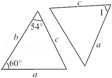Enumerate the features presented in the diagram. The diagram displays two triangles labeled as ABC and DEF. In triangle ABC, angles at points A and C are specifically marked as 54 degrees and 60 degrees respectively, suggesting it may be a scalene triangle depending on the third angle's measurement. Triangle DEF mirrors this with congruent angles at corresponding points. Each triangle's sides are labeled as a, b, and c, indicating sides of corresponding length between the two triangles, suggesting they might be congruent. The key details suggest this diagram could be used to study triangle congruence or for geometric proof exercises. 